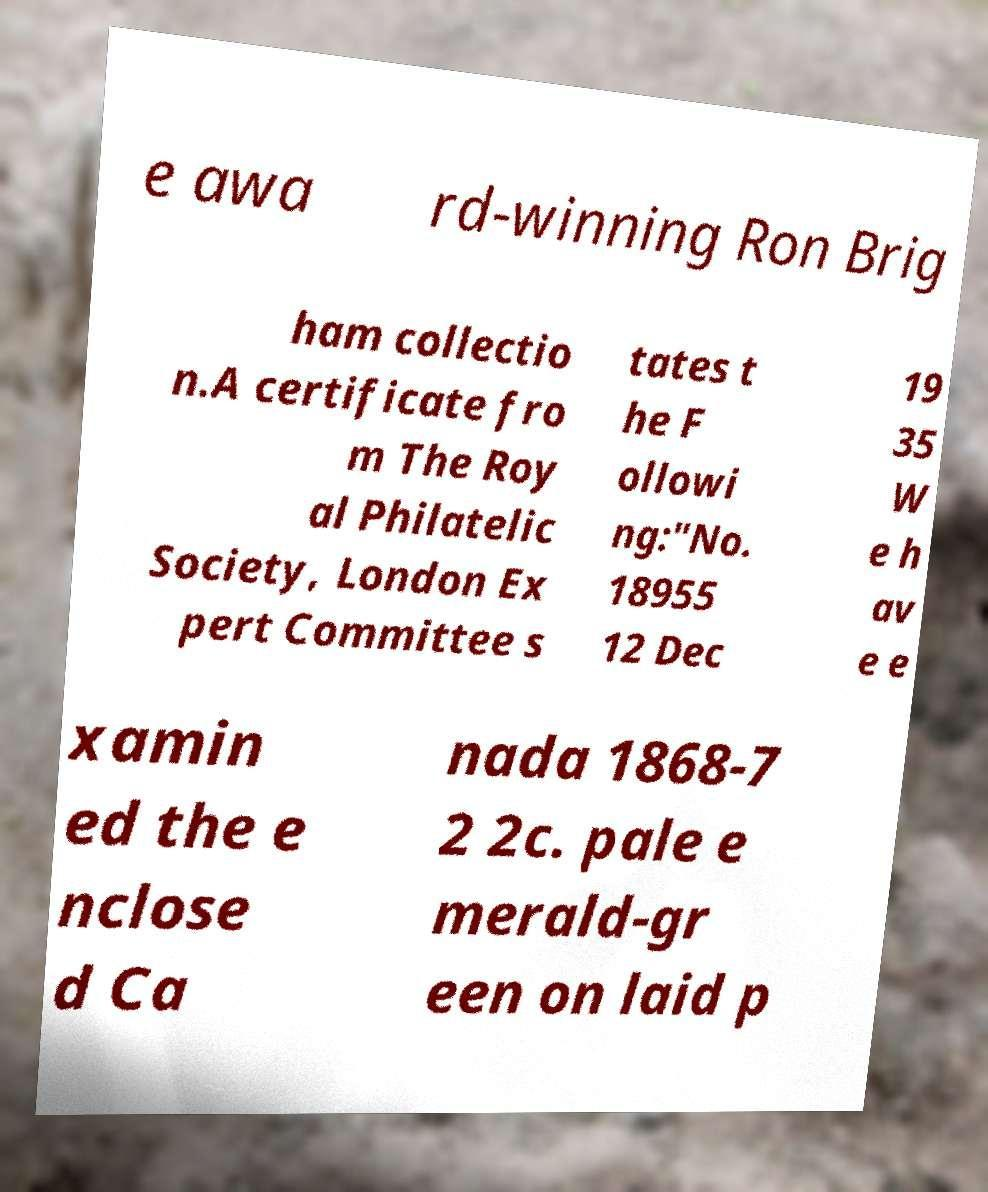Please identify and transcribe the text found in this image. e awa rd-winning Ron Brig ham collectio n.A certificate fro m The Roy al Philatelic Society, London Ex pert Committee s tates t he F ollowi ng:"No. 18955 12 Dec 19 35 W e h av e e xamin ed the e nclose d Ca nada 1868-7 2 2c. pale e merald-gr een on laid p 